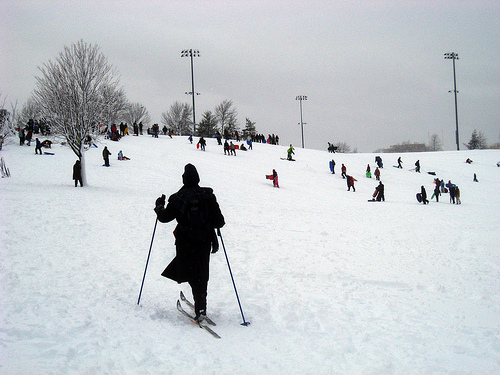Describe a realistic scenario where a family is enjoying this place. A family arrives at the snowy hill, filled with excitement for a day of fun. They unload their gear from the car, making sure everyone is bundled up in warm coats, hats, and gloves. The parents help their younger children put on skis, while the older kids eagerly grab their snowboards. They spend the morning skiing and sledding down the slopes, laughing and cheering each other on. When it's time for a break, they gather at a picnic table, enjoying hot cocoa and snacks they brought along. In the afternoon, the family builds a snowman together, adding a carrot nose and a scarf. As the day comes to an end, they pack up their gear, tired but happy, and head home, already planning their next visit to the snowy hill.  Think of a very creative and imaginative scenario in this setting. In this snowy setting, imagine a hidden portal at the top of the hill that leads to a magical winter kingdom. Upon entering, the landscape is transformed into a sparkling winter wonderland, where snowflakes are made of diamonds and ice sculptures come to life. Friendly snowy creatures greet visitors, guiding them to an ice castle where an annual winter festival is taking place. The castle is adorned with intricate ice carvings and lit by glowing icicles. Inside, there's a grand ballroom where people of the kingdom dance elegantly on the ice floor. There are enchanting performances by ice fairies and a grand feast with magical winter foods that glow and sparkle. It's a realm where winter is eternally beautiful, and everyone is invited to join in the magical celebration and explore the wonders of this hidden winter kingdom. 